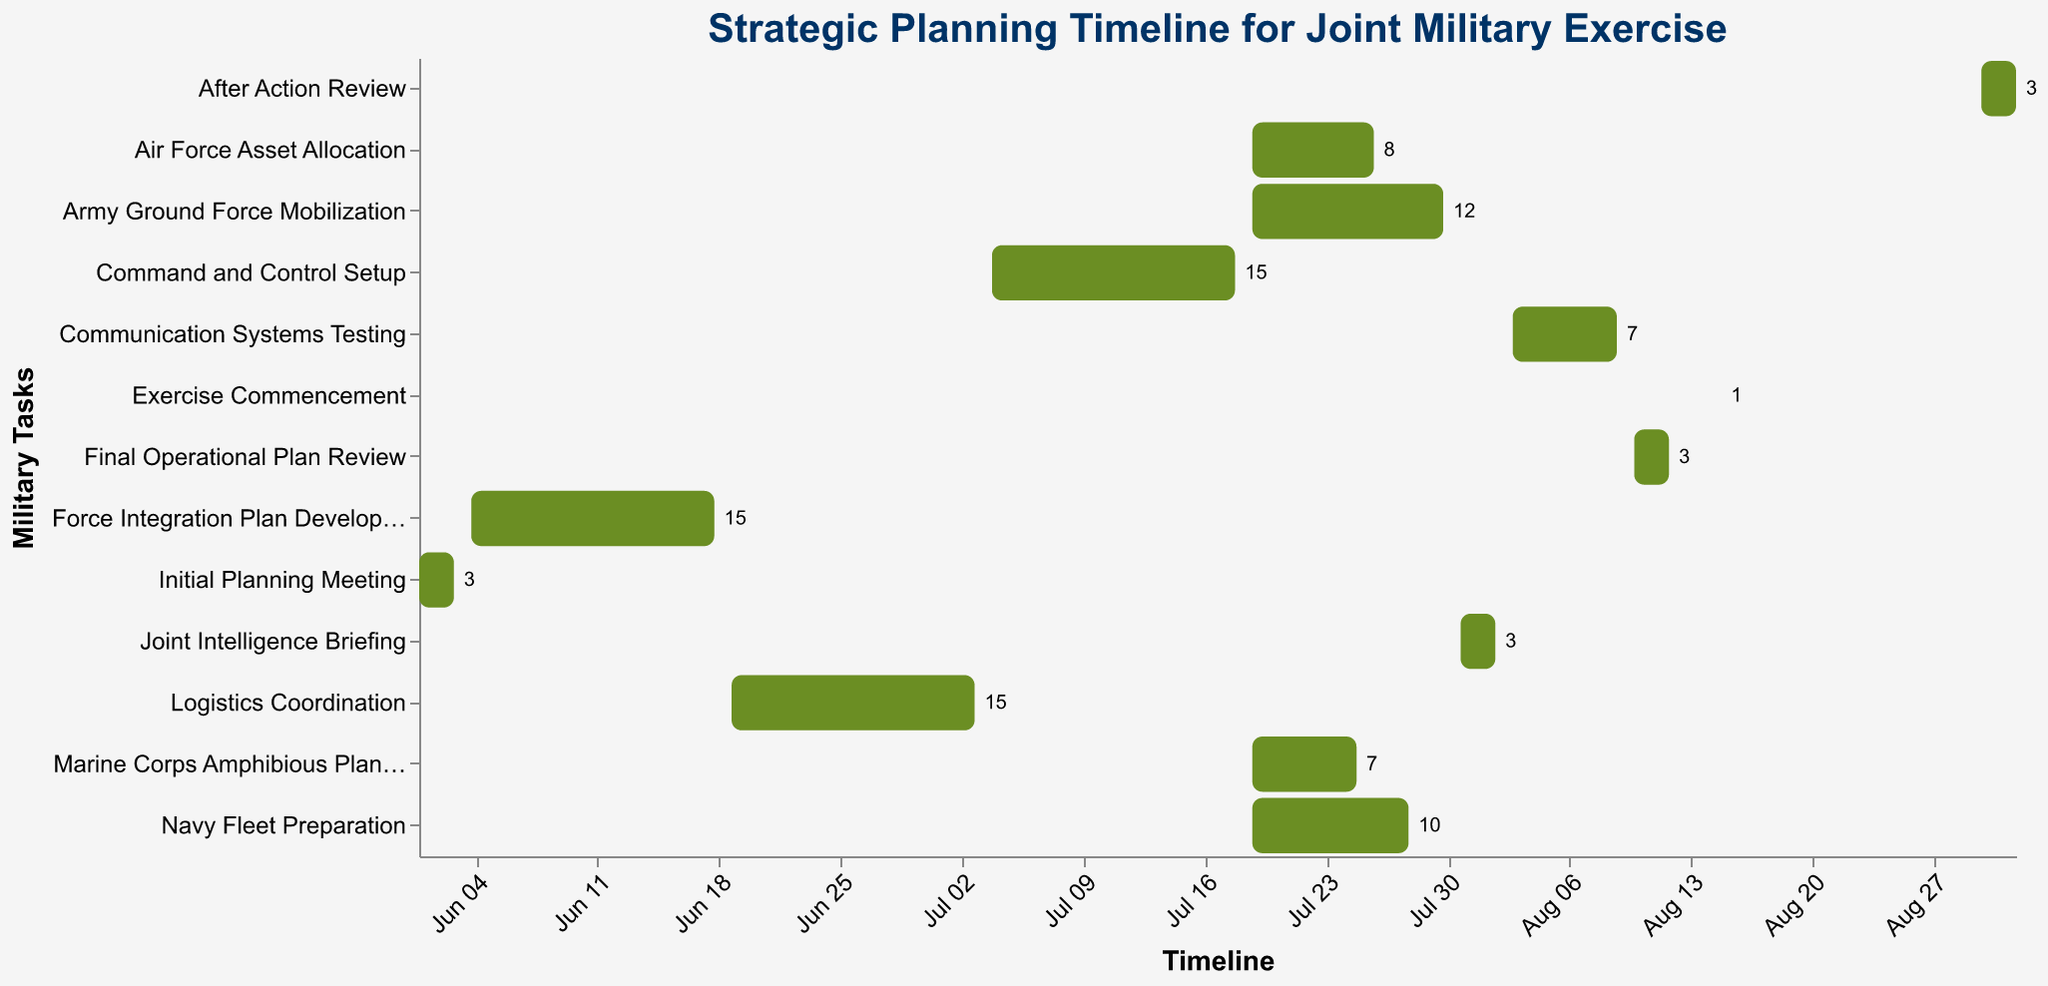What is the title of the figure? The title is prominently displayed at the top of the figure, indicating the main subject of the Gantt Chart.
Answer: Strategic Planning Timeline for Joint Military Exercise Which task has the longest duration and how many days does it last? By looking at the 'Duration' annotations next to each bar, the task with the highest number (longest bar) can be identified.
Answer: Army Ground Force Mobilization, 12 days When does the 'Logistics Coordination' task start and end? The figure shows the timeline at the bottom axis and each task's start and end dates are indicated above the bars. Locate 'Logistics Coordination' on the vertical axis and read its start and end dates.
Answer: Starts on 2023-06-19 and ends on 2023-07-03 List all tasks that overlap with 'Command and Control Setup' in their timelines. Find the start and end dates of 'Command and Control Setup' (2023-07-04 to 2023-07-18), then check which other tasks have date ranges that overlap with this period.
Answer: Air Force Asset Allocation, Navy Fleet Preparation, Army Ground Force Mobilization, Marine Corps Amphibious Planning What are the two shortest tasks in terms of duration and their respective timelines? Identify the shortest bars based on the duration numbers next to each task. The shortest overall durations are those with the smallest numbers.
Answer: 'Exercise Commencement' (1 day on 2023-08-15) and 'Initial Planning Meeting' (3 days from 2023-06-01 to 2023-06-03) Compare the duration of 'Air Force Asset Allocation' and 'Marine Corps Amphibious Planning'. Which one is longer and by how many days? Find the durations (8 days for Air Force Asset Allocation and 7 days for Marine Corps Amphibious Planning) and calculate the difference.
Answer: 'Air Force Asset Allocation' is 1 day longer What is the total duration of all tasks before 'Communication Systems Testing'? Sum up the duration of all tasks that end before 2023-08-03, which includes all tasks except 'Communication Systems Testing', 'Final Operational Plan Review', 'Exercise Commencement', and 'After Action Review'.
Answer: 78 days During which month does the 'After Action Review' take place? By looking at the 'After Action Review' task's start and end dates, the month can be determined.
Answer: September 2023 Which task immediately follows 'Final Operational Plan Review'? Identify the task that starts right after 'Final Operational Plan Review' ends on 2023-08-12.
Answer: Exercise Commencement How many tasks have a duration shorter than 10 days? Identify and count tasks with duration annotations indicating less than 10 days.
Answer: 5 tasks 